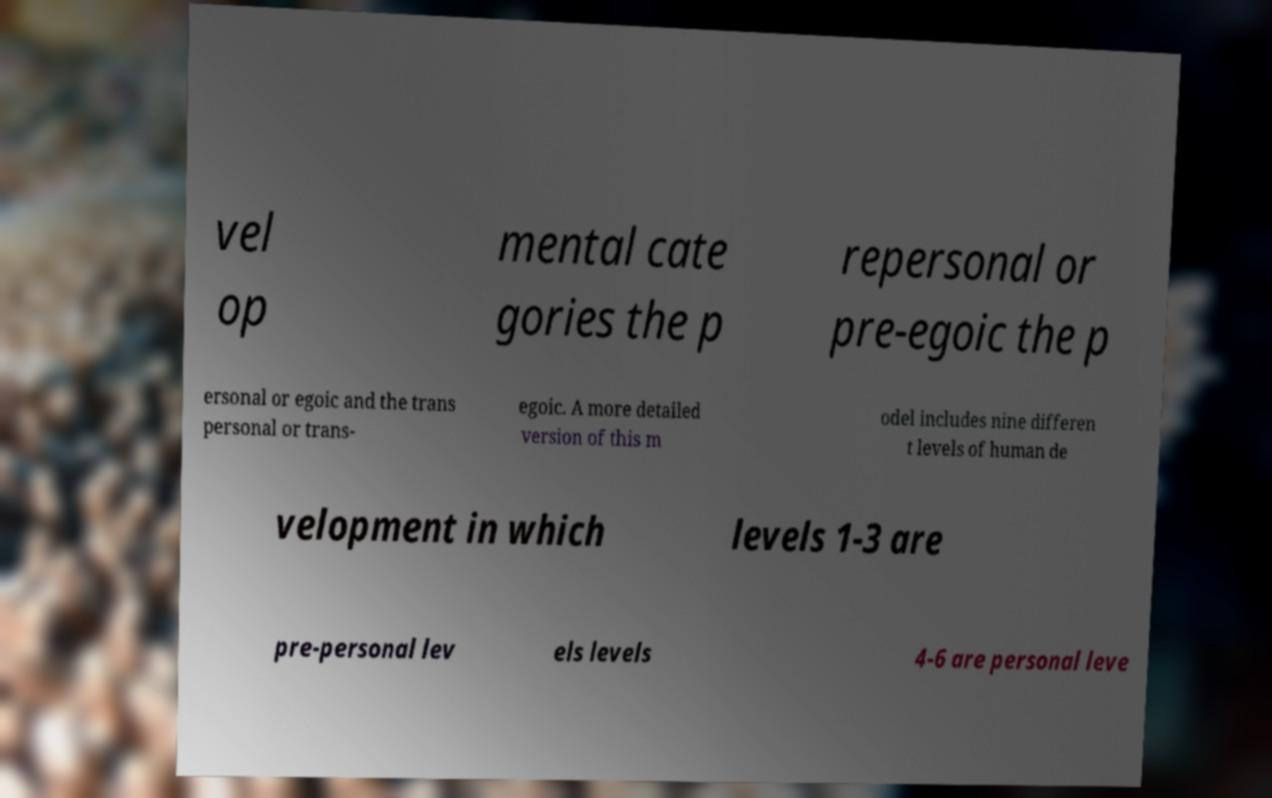Please identify and transcribe the text found in this image. vel op mental cate gories the p repersonal or pre-egoic the p ersonal or egoic and the trans personal or trans- egoic. A more detailed version of this m odel includes nine differen t levels of human de velopment in which levels 1-3 are pre-personal lev els levels 4-6 are personal leve 